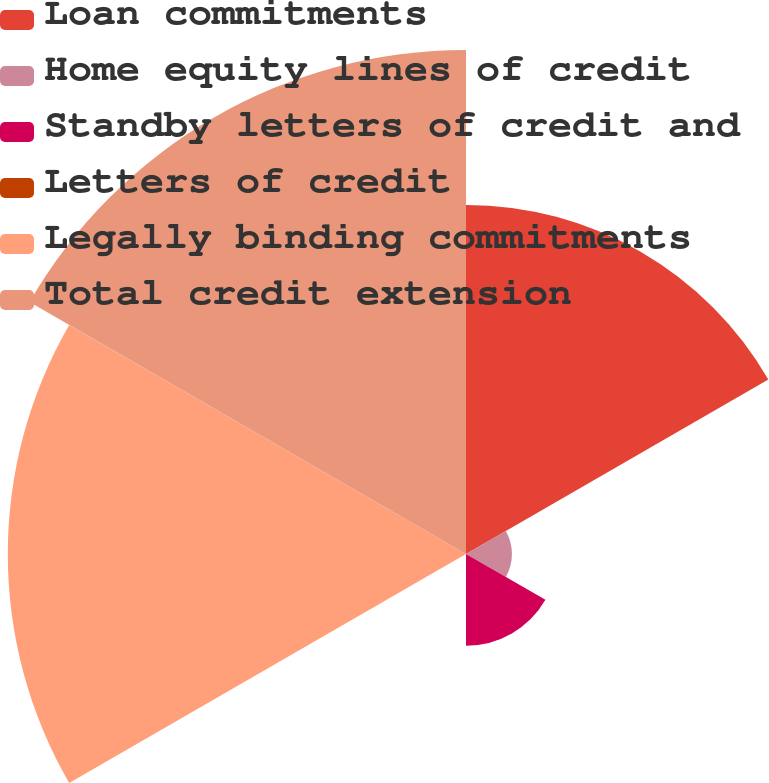<chart> <loc_0><loc_0><loc_500><loc_500><pie_chart><fcel>Loan commitments<fcel>Home equity lines of credit<fcel>Standby letters of credit and<fcel>Letters of credit<fcel>Legally binding commitments<fcel>Total credit extension<nl><fcel>24.09%<fcel>3.17%<fcel>6.33%<fcel>0.01%<fcel>31.62%<fcel>34.78%<nl></chart> 